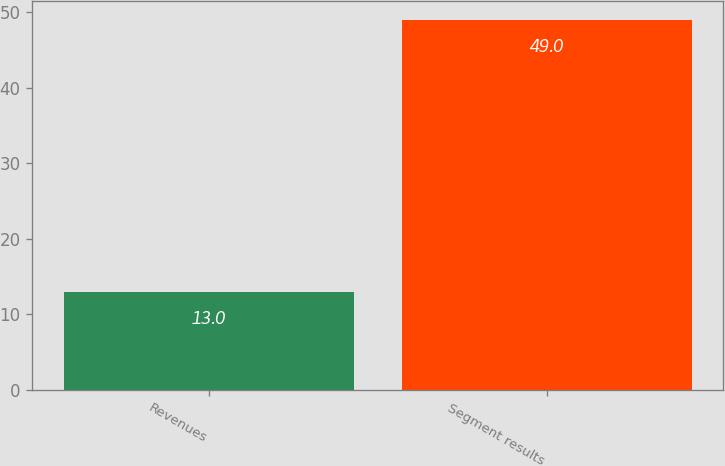Convert chart to OTSL. <chart><loc_0><loc_0><loc_500><loc_500><bar_chart><fcel>Revenues<fcel>Segment results<nl><fcel>13<fcel>49<nl></chart> 